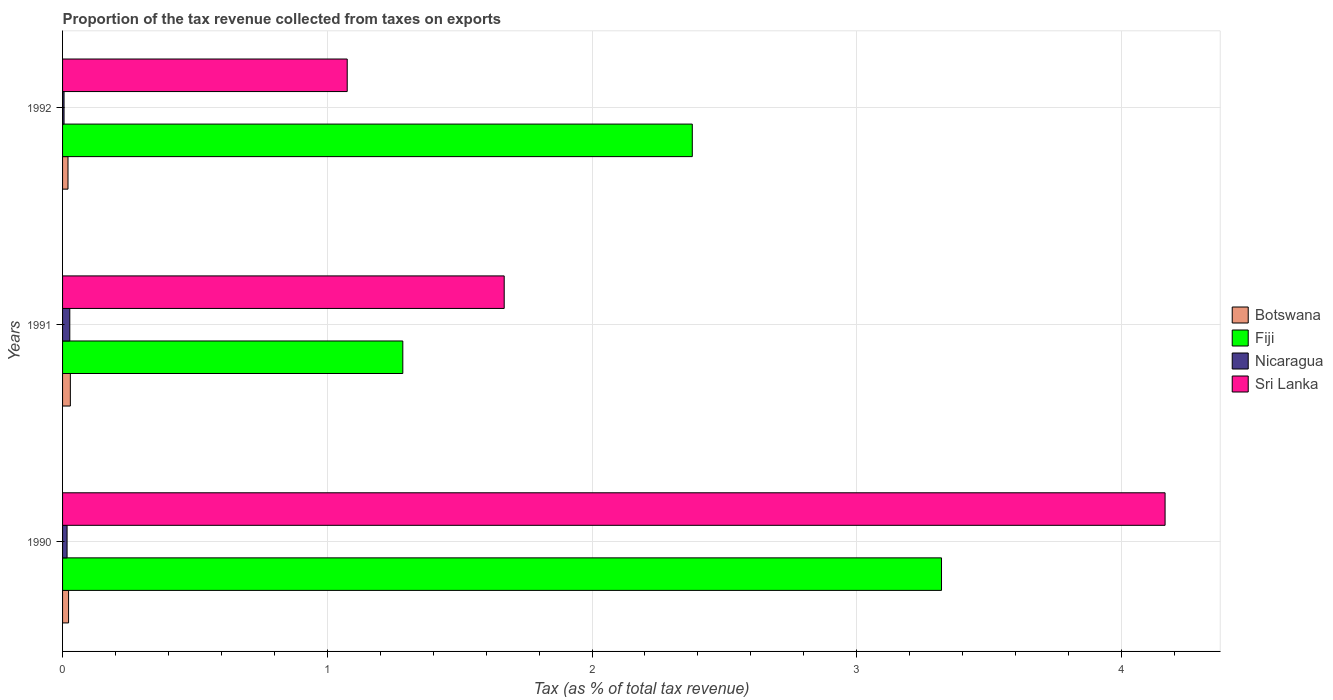Are the number of bars per tick equal to the number of legend labels?
Provide a short and direct response. Yes. Are the number of bars on each tick of the Y-axis equal?
Keep it short and to the point. Yes. How many bars are there on the 1st tick from the bottom?
Offer a very short reply. 4. What is the proportion of the tax revenue collected in Botswana in 1990?
Provide a short and direct response. 0.02. Across all years, what is the maximum proportion of the tax revenue collected in Fiji?
Keep it short and to the point. 3.32. Across all years, what is the minimum proportion of the tax revenue collected in Sri Lanka?
Keep it short and to the point. 1.08. In which year was the proportion of the tax revenue collected in Nicaragua minimum?
Your response must be concise. 1992. What is the total proportion of the tax revenue collected in Sri Lanka in the graph?
Provide a succinct answer. 6.91. What is the difference between the proportion of the tax revenue collected in Nicaragua in 1990 and that in 1992?
Ensure brevity in your answer.  0.01. What is the difference between the proportion of the tax revenue collected in Sri Lanka in 1990 and the proportion of the tax revenue collected in Botswana in 1992?
Your response must be concise. 4.14. What is the average proportion of the tax revenue collected in Nicaragua per year?
Your answer should be very brief. 0.02. In the year 1990, what is the difference between the proportion of the tax revenue collected in Fiji and proportion of the tax revenue collected in Botswana?
Provide a succinct answer. 3.3. In how many years, is the proportion of the tax revenue collected in Fiji greater than 1.6 %?
Offer a very short reply. 2. What is the ratio of the proportion of the tax revenue collected in Sri Lanka in 1990 to that in 1992?
Your response must be concise. 3.87. Is the proportion of the tax revenue collected in Fiji in 1990 less than that in 1991?
Make the answer very short. No. What is the difference between the highest and the second highest proportion of the tax revenue collected in Nicaragua?
Keep it short and to the point. 0.01. What is the difference between the highest and the lowest proportion of the tax revenue collected in Nicaragua?
Your response must be concise. 0.02. In how many years, is the proportion of the tax revenue collected in Nicaragua greater than the average proportion of the tax revenue collected in Nicaragua taken over all years?
Give a very brief answer. 2. Is the sum of the proportion of the tax revenue collected in Fiji in 1990 and 1992 greater than the maximum proportion of the tax revenue collected in Sri Lanka across all years?
Offer a terse response. Yes. Is it the case that in every year, the sum of the proportion of the tax revenue collected in Sri Lanka and proportion of the tax revenue collected in Botswana is greater than the sum of proportion of the tax revenue collected in Fiji and proportion of the tax revenue collected in Nicaragua?
Offer a very short reply. Yes. What does the 4th bar from the top in 1992 represents?
Provide a succinct answer. Botswana. What does the 2nd bar from the bottom in 1992 represents?
Your answer should be very brief. Fiji. How many bars are there?
Offer a very short reply. 12. What is the difference between two consecutive major ticks on the X-axis?
Give a very brief answer. 1. Are the values on the major ticks of X-axis written in scientific E-notation?
Offer a very short reply. No. Does the graph contain grids?
Your response must be concise. Yes. How are the legend labels stacked?
Give a very brief answer. Vertical. What is the title of the graph?
Provide a short and direct response. Proportion of the tax revenue collected from taxes on exports. Does "Northern Mariana Islands" appear as one of the legend labels in the graph?
Ensure brevity in your answer.  No. What is the label or title of the X-axis?
Keep it short and to the point. Tax (as % of total tax revenue). What is the Tax (as % of total tax revenue) in Botswana in 1990?
Keep it short and to the point. 0.02. What is the Tax (as % of total tax revenue) of Fiji in 1990?
Make the answer very short. 3.32. What is the Tax (as % of total tax revenue) of Nicaragua in 1990?
Your answer should be very brief. 0.02. What is the Tax (as % of total tax revenue) of Sri Lanka in 1990?
Keep it short and to the point. 4.16. What is the Tax (as % of total tax revenue) in Botswana in 1991?
Keep it short and to the point. 0.03. What is the Tax (as % of total tax revenue) of Fiji in 1991?
Your response must be concise. 1.29. What is the Tax (as % of total tax revenue) of Nicaragua in 1991?
Give a very brief answer. 0.03. What is the Tax (as % of total tax revenue) of Sri Lanka in 1991?
Your response must be concise. 1.67. What is the Tax (as % of total tax revenue) in Botswana in 1992?
Your answer should be compact. 0.02. What is the Tax (as % of total tax revenue) of Fiji in 1992?
Offer a terse response. 2.38. What is the Tax (as % of total tax revenue) of Nicaragua in 1992?
Give a very brief answer. 0.01. What is the Tax (as % of total tax revenue) of Sri Lanka in 1992?
Provide a succinct answer. 1.08. Across all years, what is the maximum Tax (as % of total tax revenue) in Botswana?
Your answer should be compact. 0.03. Across all years, what is the maximum Tax (as % of total tax revenue) of Fiji?
Keep it short and to the point. 3.32. Across all years, what is the maximum Tax (as % of total tax revenue) of Nicaragua?
Your answer should be compact. 0.03. Across all years, what is the maximum Tax (as % of total tax revenue) of Sri Lanka?
Your response must be concise. 4.16. Across all years, what is the minimum Tax (as % of total tax revenue) in Botswana?
Your answer should be very brief. 0.02. Across all years, what is the minimum Tax (as % of total tax revenue) in Fiji?
Ensure brevity in your answer.  1.29. Across all years, what is the minimum Tax (as % of total tax revenue) of Nicaragua?
Provide a succinct answer. 0.01. Across all years, what is the minimum Tax (as % of total tax revenue) in Sri Lanka?
Offer a very short reply. 1.08. What is the total Tax (as % of total tax revenue) in Botswana in the graph?
Offer a very short reply. 0.07. What is the total Tax (as % of total tax revenue) in Fiji in the graph?
Your answer should be compact. 6.98. What is the total Tax (as % of total tax revenue) of Sri Lanka in the graph?
Offer a terse response. 6.91. What is the difference between the Tax (as % of total tax revenue) in Botswana in 1990 and that in 1991?
Your answer should be very brief. -0.01. What is the difference between the Tax (as % of total tax revenue) in Fiji in 1990 and that in 1991?
Provide a short and direct response. 2.03. What is the difference between the Tax (as % of total tax revenue) in Nicaragua in 1990 and that in 1991?
Give a very brief answer. -0.01. What is the difference between the Tax (as % of total tax revenue) of Sri Lanka in 1990 and that in 1991?
Your answer should be very brief. 2.5. What is the difference between the Tax (as % of total tax revenue) in Botswana in 1990 and that in 1992?
Your answer should be compact. 0. What is the difference between the Tax (as % of total tax revenue) of Fiji in 1990 and that in 1992?
Keep it short and to the point. 0.94. What is the difference between the Tax (as % of total tax revenue) of Nicaragua in 1990 and that in 1992?
Ensure brevity in your answer.  0.01. What is the difference between the Tax (as % of total tax revenue) in Sri Lanka in 1990 and that in 1992?
Provide a succinct answer. 3.09. What is the difference between the Tax (as % of total tax revenue) of Botswana in 1991 and that in 1992?
Your response must be concise. 0.01. What is the difference between the Tax (as % of total tax revenue) of Fiji in 1991 and that in 1992?
Provide a succinct answer. -1.09. What is the difference between the Tax (as % of total tax revenue) of Nicaragua in 1991 and that in 1992?
Make the answer very short. 0.02. What is the difference between the Tax (as % of total tax revenue) in Sri Lanka in 1991 and that in 1992?
Offer a terse response. 0.59. What is the difference between the Tax (as % of total tax revenue) of Botswana in 1990 and the Tax (as % of total tax revenue) of Fiji in 1991?
Your answer should be very brief. -1.26. What is the difference between the Tax (as % of total tax revenue) in Botswana in 1990 and the Tax (as % of total tax revenue) in Nicaragua in 1991?
Keep it short and to the point. -0. What is the difference between the Tax (as % of total tax revenue) of Botswana in 1990 and the Tax (as % of total tax revenue) of Sri Lanka in 1991?
Give a very brief answer. -1.65. What is the difference between the Tax (as % of total tax revenue) in Fiji in 1990 and the Tax (as % of total tax revenue) in Nicaragua in 1991?
Offer a very short reply. 3.29. What is the difference between the Tax (as % of total tax revenue) of Fiji in 1990 and the Tax (as % of total tax revenue) of Sri Lanka in 1991?
Offer a very short reply. 1.65. What is the difference between the Tax (as % of total tax revenue) in Nicaragua in 1990 and the Tax (as % of total tax revenue) in Sri Lanka in 1991?
Offer a terse response. -1.65. What is the difference between the Tax (as % of total tax revenue) of Botswana in 1990 and the Tax (as % of total tax revenue) of Fiji in 1992?
Keep it short and to the point. -2.36. What is the difference between the Tax (as % of total tax revenue) of Botswana in 1990 and the Tax (as % of total tax revenue) of Nicaragua in 1992?
Your answer should be very brief. 0.02. What is the difference between the Tax (as % of total tax revenue) of Botswana in 1990 and the Tax (as % of total tax revenue) of Sri Lanka in 1992?
Offer a terse response. -1.05. What is the difference between the Tax (as % of total tax revenue) in Fiji in 1990 and the Tax (as % of total tax revenue) in Nicaragua in 1992?
Make the answer very short. 3.31. What is the difference between the Tax (as % of total tax revenue) in Fiji in 1990 and the Tax (as % of total tax revenue) in Sri Lanka in 1992?
Offer a terse response. 2.24. What is the difference between the Tax (as % of total tax revenue) in Nicaragua in 1990 and the Tax (as % of total tax revenue) in Sri Lanka in 1992?
Your answer should be compact. -1.06. What is the difference between the Tax (as % of total tax revenue) of Botswana in 1991 and the Tax (as % of total tax revenue) of Fiji in 1992?
Provide a succinct answer. -2.35. What is the difference between the Tax (as % of total tax revenue) of Botswana in 1991 and the Tax (as % of total tax revenue) of Nicaragua in 1992?
Give a very brief answer. 0.02. What is the difference between the Tax (as % of total tax revenue) in Botswana in 1991 and the Tax (as % of total tax revenue) in Sri Lanka in 1992?
Your response must be concise. -1.05. What is the difference between the Tax (as % of total tax revenue) in Fiji in 1991 and the Tax (as % of total tax revenue) in Nicaragua in 1992?
Your response must be concise. 1.28. What is the difference between the Tax (as % of total tax revenue) of Fiji in 1991 and the Tax (as % of total tax revenue) of Sri Lanka in 1992?
Your answer should be compact. 0.21. What is the difference between the Tax (as % of total tax revenue) of Nicaragua in 1991 and the Tax (as % of total tax revenue) of Sri Lanka in 1992?
Ensure brevity in your answer.  -1.05. What is the average Tax (as % of total tax revenue) in Botswana per year?
Provide a short and direct response. 0.02. What is the average Tax (as % of total tax revenue) of Fiji per year?
Offer a very short reply. 2.33. What is the average Tax (as % of total tax revenue) in Nicaragua per year?
Make the answer very short. 0.02. What is the average Tax (as % of total tax revenue) in Sri Lanka per year?
Give a very brief answer. 2.3. In the year 1990, what is the difference between the Tax (as % of total tax revenue) of Botswana and Tax (as % of total tax revenue) of Fiji?
Provide a succinct answer. -3.3. In the year 1990, what is the difference between the Tax (as % of total tax revenue) in Botswana and Tax (as % of total tax revenue) in Nicaragua?
Offer a terse response. 0.01. In the year 1990, what is the difference between the Tax (as % of total tax revenue) of Botswana and Tax (as % of total tax revenue) of Sri Lanka?
Your answer should be compact. -4.14. In the year 1990, what is the difference between the Tax (as % of total tax revenue) of Fiji and Tax (as % of total tax revenue) of Nicaragua?
Offer a very short reply. 3.3. In the year 1990, what is the difference between the Tax (as % of total tax revenue) in Fiji and Tax (as % of total tax revenue) in Sri Lanka?
Give a very brief answer. -0.84. In the year 1990, what is the difference between the Tax (as % of total tax revenue) of Nicaragua and Tax (as % of total tax revenue) of Sri Lanka?
Offer a terse response. -4.15. In the year 1991, what is the difference between the Tax (as % of total tax revenue) of Botswana and Tax (as % of total tax revenue) of Fiji?
Keep it short and to the point. -1.26. In the year 1991, what is the difference between the Tax (as % of total tax revenue) in Botswana and Tax (as % of total tax revenue) in Nicaragua?
Your answer should be compact. 0. In the year 1991, what is the difference between the Tax (as % of total tax revenue) in Botswana and Tax (as % of total tax revenue) in Sri Lanka?
Make the answer very short. -1.64. In the year 1991, what is the difference between the Tax (as % of total tax revenue) in Fiji and Tax (as % of total tax revenue) in Nicaragua?
Offer a very short reply. 1.26. In the year 1991, what is the difference between the Tax (as % of total tax revenue) in Fiji and Tax (as % of total tax revenue) in Sri Lanka?
Provide a short and direct response. -0.38. In the year 1991, what is the difference between the Tax (as % of total tax revenue) in Nicaragua and Tax (as % of total tax revenue) in Sri Lanka?
Give a very brief answer. -1.64. In the year 1992, what is the difference between the Tax (as % of total tax revenue) in Botswana and Tax (as % of total tax revenue) in Fiji?
Your answer should be very brief. -2.36. In the year 1992, what is the difference between the Tax (as % of total tax revenue) of Botswana and Tax (as % of total tax revenue) of Nicaragua?
Offer a very short reply. 0.01. In the year 1992, what is the difference between the Tax (as % of total tax revenue) of Botswana and Tax (as % of total tax revenue) of Sri Lanka?
Your answer should be compact. -1.05. In the year 1992, what is the difference between the Tax (as % of total tax revenue) in Fiji and Tax (as % of total tax revenue) in Nicaragua?
Your response must be concise. 2.37. In the year 1992, what is the difference between the Tax (as % of total tax revenue) in Fiji and Tax (as % of total tax revenue) in Sri Lanka?
Offer a terse response. 1.3. In the year 1992, what is the difference between the Tax (as % of total tax revenue) of Nicaragua and Tax (as % of total tax revenue) of Sri Lanka?
Your response must be concise. -1.07. What is the ratio of the Tax (as % of total tax revenue) of Botswana in 1990 to that in 1991?
Your answer should be compact. 0.77. What is the ratio of the Tax (as % of total tax revenue) of Fiji in 1990 to that in 1991?
Ensure brevity in your answer.  2.58. What is the ratio of the Tax (as % of total tax revenue) of Nicaragua in 1990 to that in 1991?
Keep it short and to the point. 0.62. What is the ratio of the Tax (as % of total tax revenue) in Sri Lanka in 1990 to that in 1991?
Offer a terse response. 2.5. What is the ratio of the Tax (as % of total tax revenue) in Botswana in 1990 to that in 1992?
Make the answer very short. 1.11. What is the ratio of the Tax (as % of total tax revenue) of Fiji in 1990 to that in 1992?
Ensure brevity in your answer.  1.4. What is the ratio of the Tax (as % of total tax revenue) in Nicaragua in 1990 to that in 1992?
Ensure brevity in your answer.  3.03. What is the ratio of the Tax (as % of total tax revenue) in Sri Lanka in 1990 to that in 1992?
Make the answer very short. 3.87. What is the ratio of the Tax (as % of total tax revenue) in Botswana in 1991 to that in 1992?
Offer a very short reply. 1.43. What is the ratio of the Tax (as % of total tax revenue) of Fiji in 1991 to that in 1992?
Give a very brief answer. 0.54. What is the ratio of the Tax (as % of total tax revenue) in Nicaragua in 1991 to that in 1992?
Your answer should be compact. 4.86. What is the ratio of the Tax (as % of total tax revenue) of Sri Lanka in 1991 to that in 1992?
Ensure brevity in your answer.  1.55. What is the difference between the highest and the second highest Tax (as % of total tax revenue) of Botswana?
Give a very brief answer. 0.01. What is the difference between the highest and the second highest Tax (as % of total tax revenue) in Fiji?
Make the answer very short. 0.94. What is the difference between the highest and the second highest Tax (as % of total tax revenue) in Nicaragua?
Keep it short and to the point. 0.01. What is the difference between the highest and the second highest Tax (as % of total tax revenue) in Sri Lanka?
Provide a succinct answer. 2.5. What is the difference between the highest and the lowest Tax (as % of total tax revenue) in Botswana?
Your answer should be very brief. 0.01. What is the difference between the highest and the lowest Tax (as % of total tax revenue) of Fiji?
Offer a very short reply. 2.03. What is the difference between the highest and the lowest Tax (as % of total tax revenue) of Nicaragua?
Offer a terse response. 0.02. What is the difference between the highest and the lowest Tax (as % of total tax revenue) of Sri Lanka?
Give a very brief answer. 3.09. 